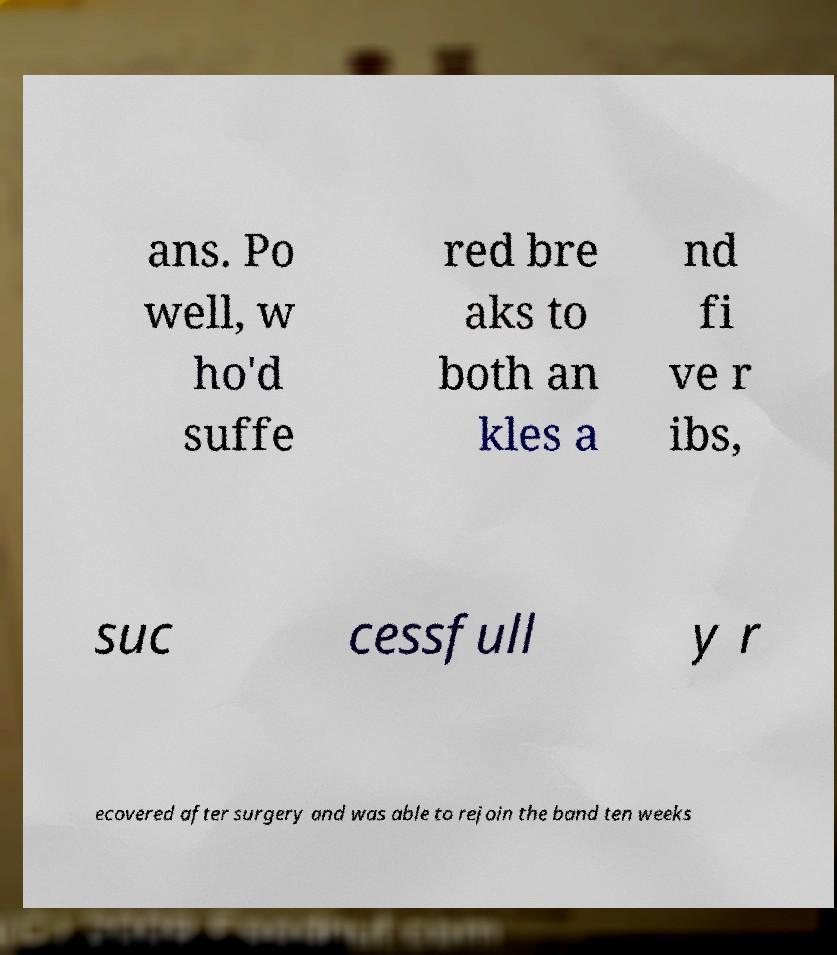What messages or text are displayed in this image? I need them in a readable, typed format. ans. Po well, w ho'd suffe red bre aks to both an kles a nd fi ve r ibs, suc cessfull y r ecovered after surgery and was able to rejoin the band ten weeks 